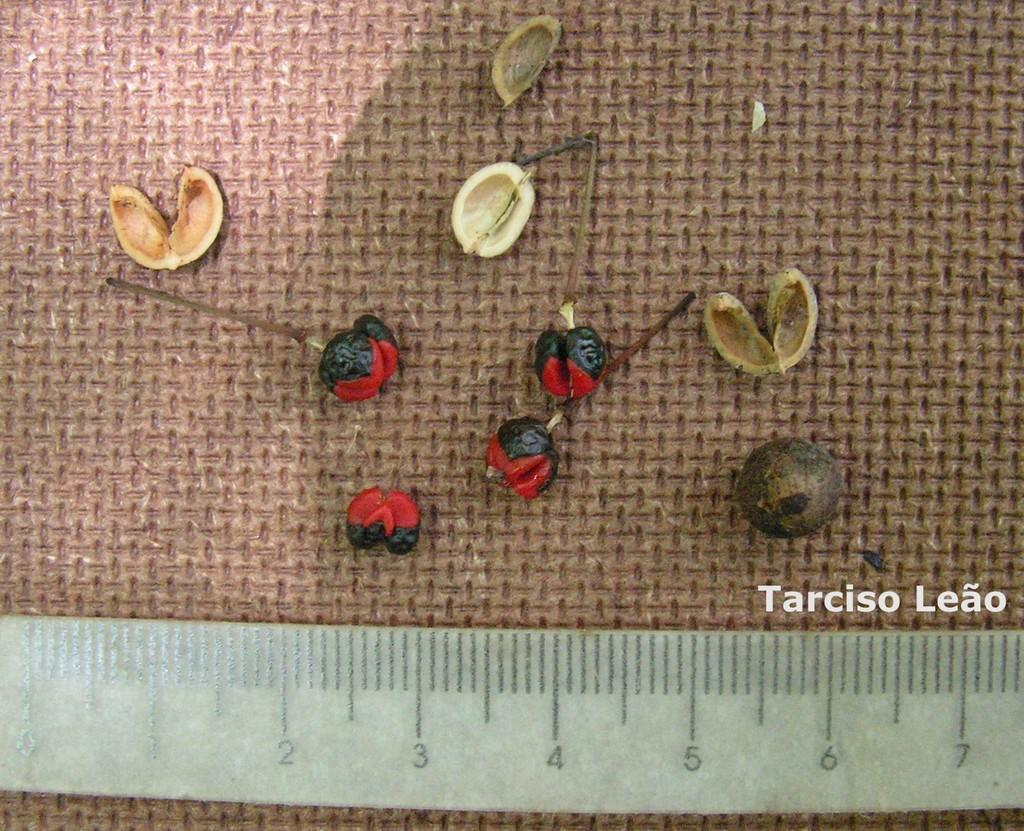<image>
Give a short and clear explanation of the subsequent image. Items used by Tarciso Leao for pins and nuts. 